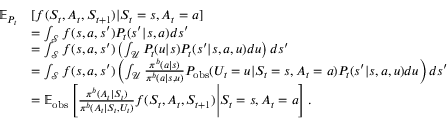Convert formula to latex. <formula><loc_0><loc_0><loc_500><loc_500>\begin{array} { r l } { \mathbb { E } _ { P _ { t } } } & { [ f ( S _ { t } , A _ { t } , S _ { t + 1 } ) | S _ { t } = s , A _ { t } = a ] } \\ & { = \int _ { \mathcal { S } } f ( s , a , s ^ { \prime } ) P _ { t } ( s ^ { \prime } | s , a ) d s ^ { \prime } } \\ & { = \int _ { \mathcal { S } } f ( s , a , s ^ { \prime } ) \left ( \int _ { \mathcal { U } } P _ { t } ( u | s ) P _ { t } ( s ^ { \prime } | s , a , u ) d u \right ) d s ^ { \prime } } \\ & { = \int _ { \mathcal { S } } f ( s , a , s ^ { \prime } ) \left ( \int _ { \mathcal { U } } \frac { \pi ^ { b } ( a | s ) } { \pi ^ { b } ( a | s , u ) } P _ { o b s } ( U _ { t } = u | S _ { t } = s , A _ { t } = a ) P _ { t } ( s ^ { \prime } | s , a , u ) d u \right ) d s ^ { \prime } } \\ & { = \mathbb { E } _ { o b s } \left [ \frac { \pi ^ { b } ( A _ { t } | S _ { t } ) } { \pi ^ { b } ( A _ { t } | S _ { t } , U _ { t } ) } f ( S _ { t } , A _ { t } , S _ { t + 1 } ) \Big | S _ { t } = s , A _ { t } = a \right ] . } \end{array}</formula> 